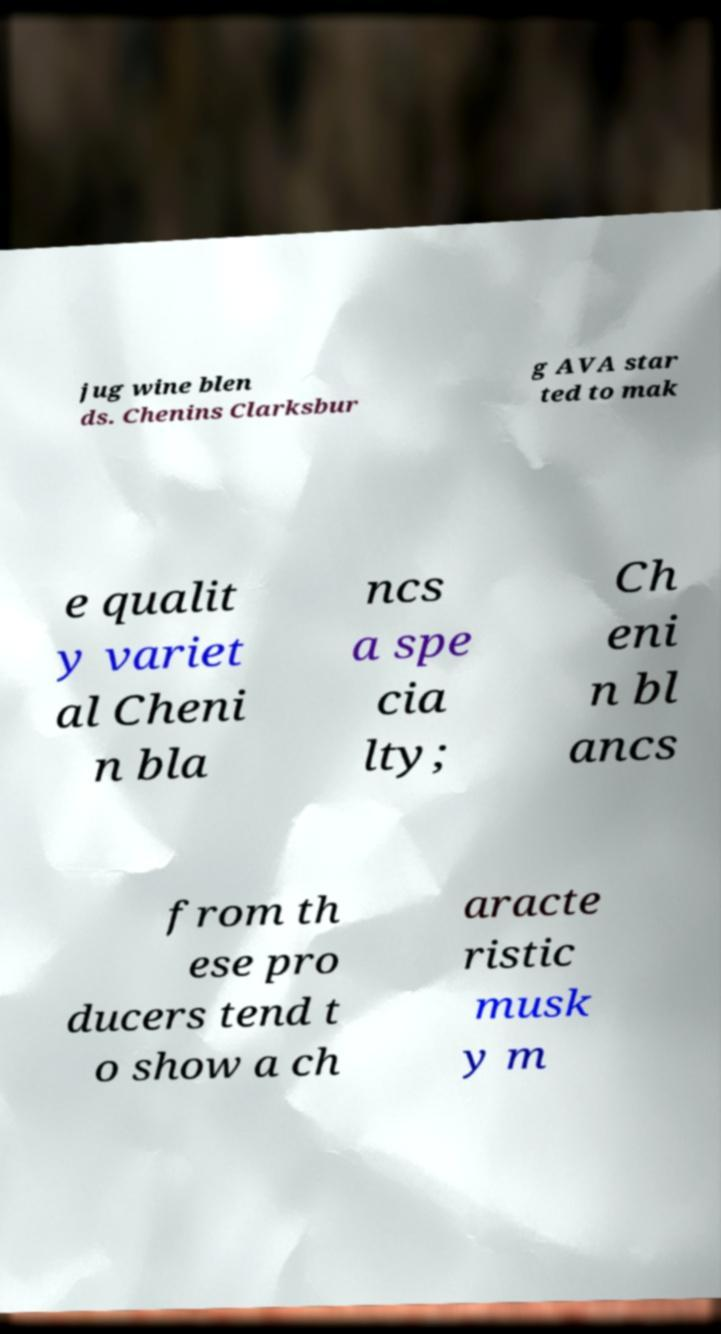For documentation purposes, I need the text within this image transcribed. Could you provide that? jug wine blen ds. Chenins Clarksbur g AVA star ted to mak e qualit y variet al Cheni n bla ncs a spe cia lty; Ch eni n bl ancs from th ese pro ducers tend t o show a ch aracte ristic musk y m 